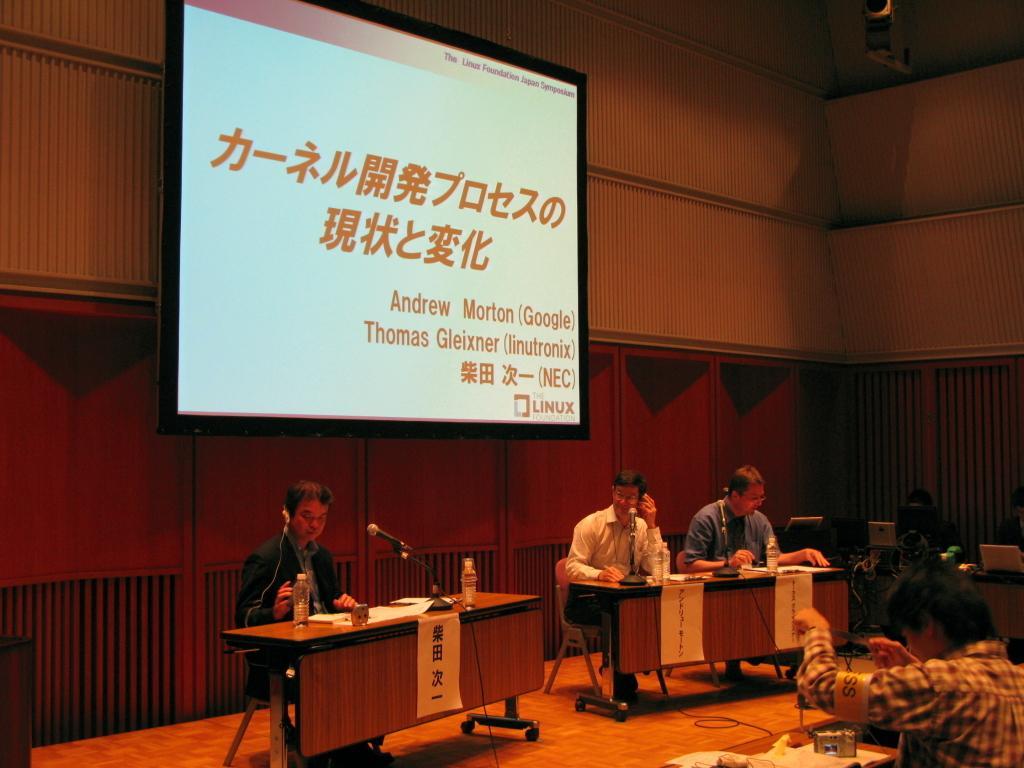Could you give a brief overview of what you see in this image? This is an inside view. At the bottom there are few people sitting on the chairs and there are few tables on which microphones, bottles, papers and some other objects are placed and also there are few monitors. At the top of the image there is a screen attached to the wall. On the screen there is some text. 